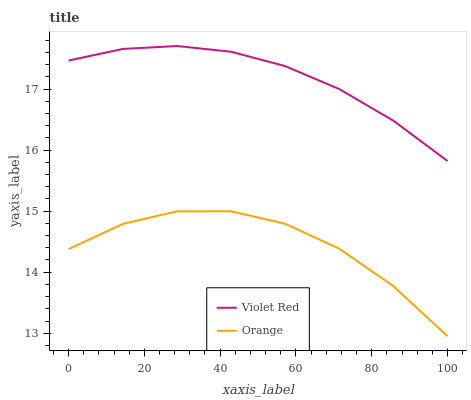Does Orange have the minimum area under the curve?
Answer yes or no. Yes. Does Violet Red have the maximum area under the curve?
Answer yes or no. Yes. Does Violet Red have the minimum area under the curve?
Answer yes or no. No. Is Violet Red the smoothest?
Answer yes or no. Yes. Is Orange the roughest?
Answer yes or no. Yes. Is Violet Red the roughest?
Answer yes or no. No. Does Orange have the lowest value?
Answer yes or no. Yes. Does Violet Red have the lowest value?
Answer yes or no. No. Does Violet Red have the highest value?
Answer yes or no. Yes. Is Orange less than Violet Red?
Answer yes or no. Yes. Is Violet Red greater than Orange?
Answer yes or no. Yes. Does Orange intersect Violet Red?
Answer yes or no. No. 